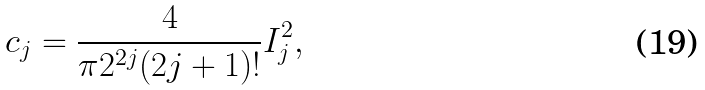<formula> <loc_0><loc_0><loc_500><loc_500>c _ { j } = \frac { 4 } { \pi 2 ^ { 2 j } ( 2 j + 1 ) ! } I _ { j } ^ { 2 } ,</formula> 